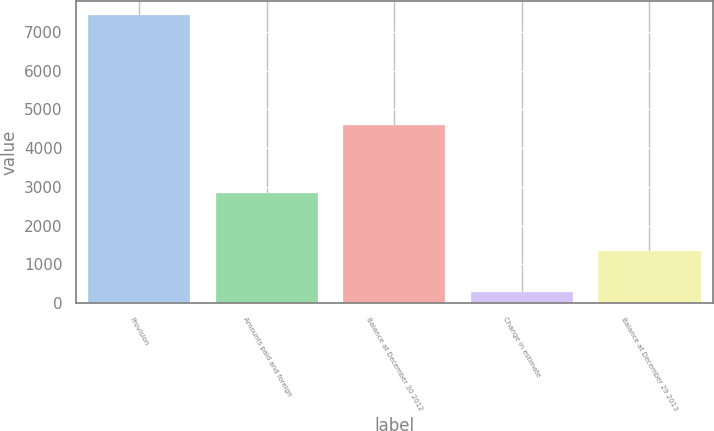Convert chart. <chart><loc_0><loc_0><loc_500><loc_500><bar_chart><fcel>Provision<fcel>Amounts paid and foreign<fcel>Balance at December 30 2012<fcel>Change in estimate<fcel>Balance at December 29 2013<nl><fcel>7422<fcel>2836<fcel>4586<fcel>294<fcel>1335<nl></chart> 